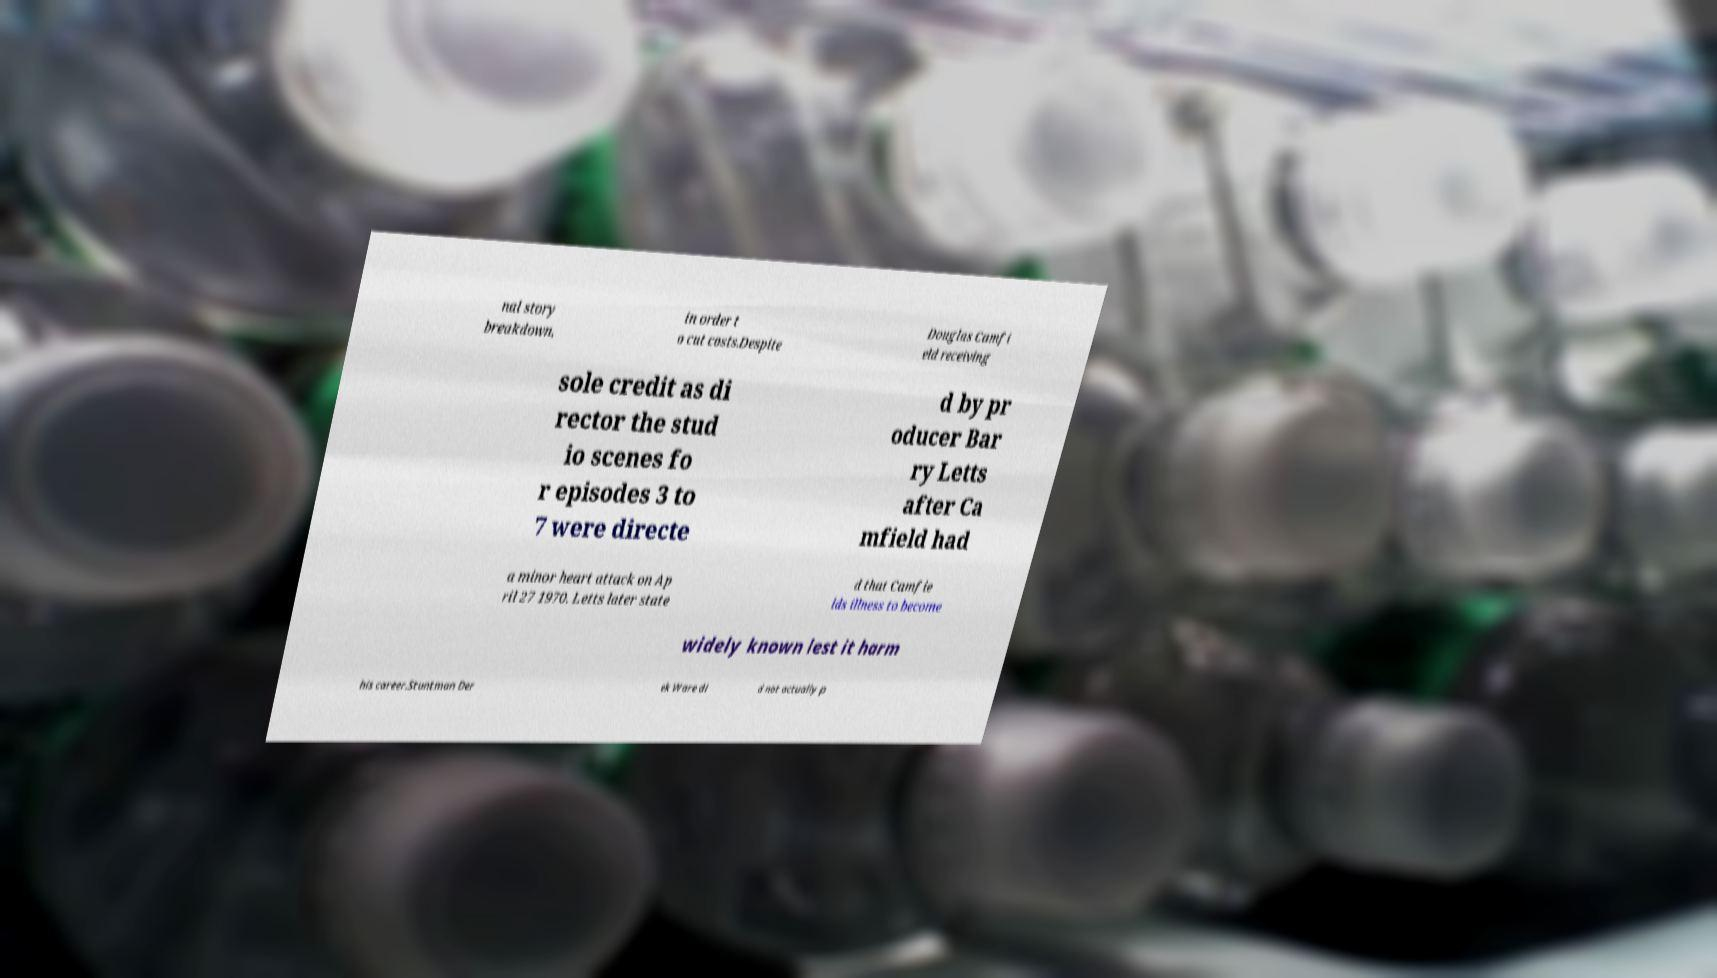I need the written content from this picture converted into text. Can you do that? nal story breakdown, in order t o cut costs.Despite Douglas Camfi eld receiving sole credit as di rector the stud io scenes fo r episodes 3 to 7 were directe d by pr oducer Bar ry Letts after Ca mfield had a minor heart attack on Ap ril 27 1970. Letts later state d that Camfie lds illness to become widely known lest it harm his career.Stuntman Der ek Ware di d not actually p 